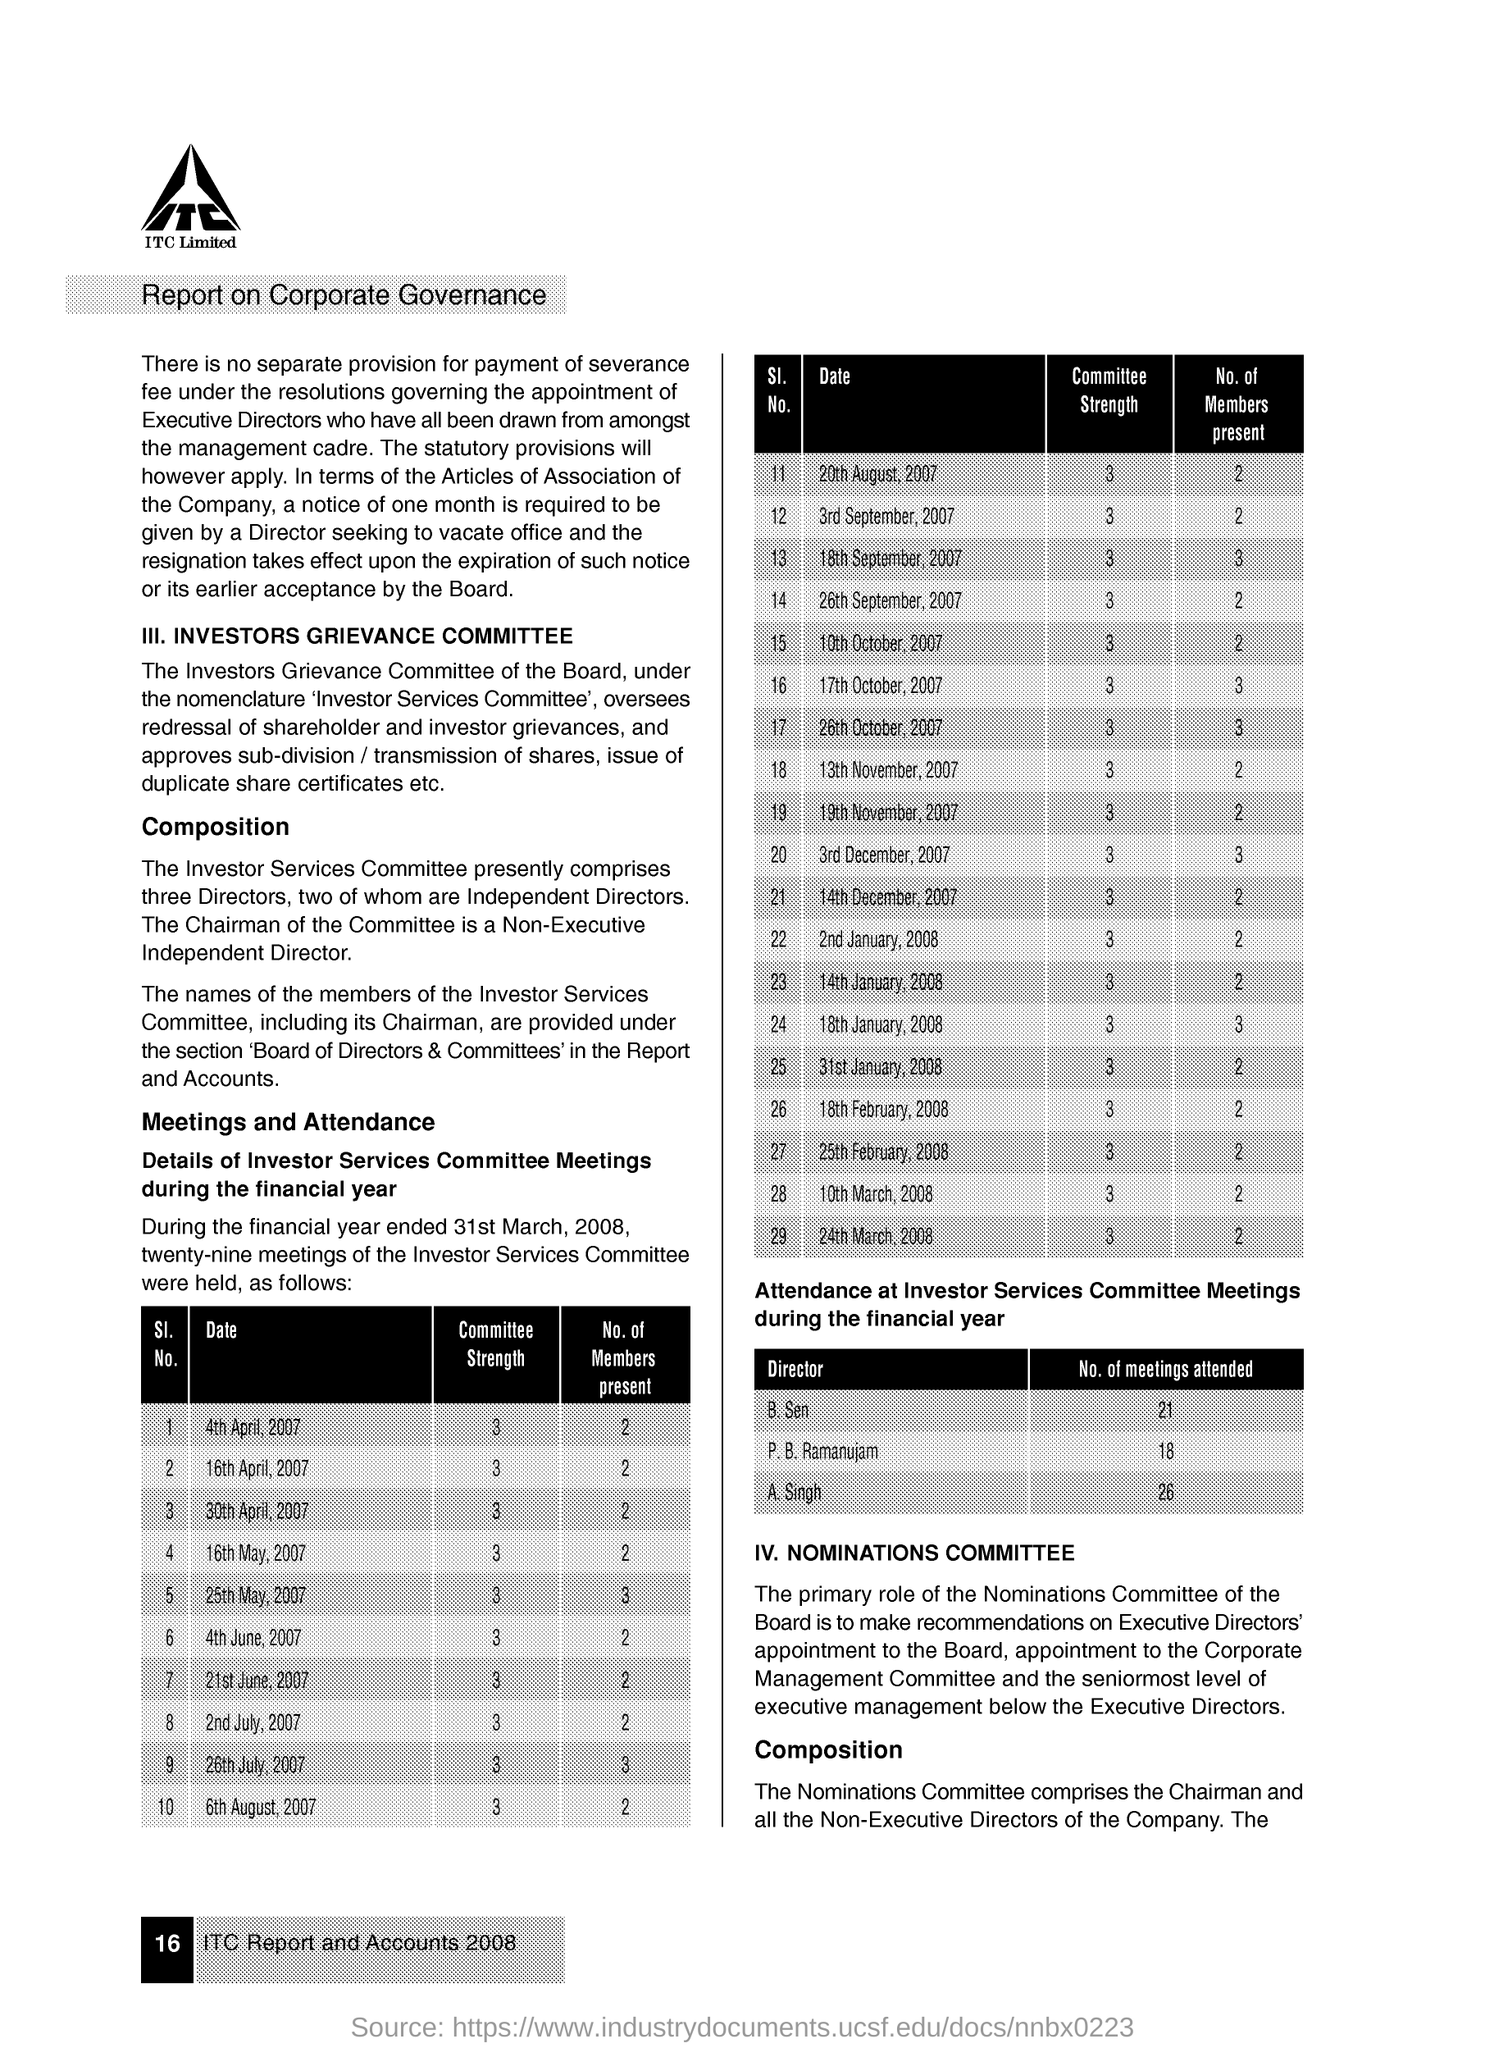Highlight a few significant elements in this photo. As of December 3, 2007, the committee's strength was [insert specific number here]. On June 21, 2007, the investors service committee meetings had a total of two members in attendance. On January 18th, 2008, the investors service committee had three members present for its meeting. On August 20th, 2007, the committee had a strength of 3. B. sen has attended 21 meetings. 